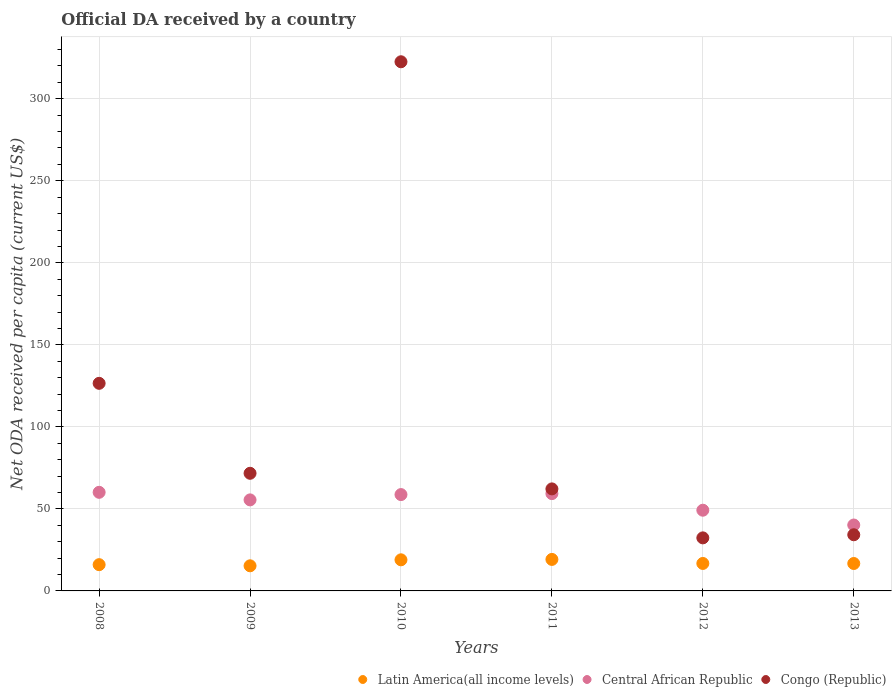How many different coloured dotlines are there?
Your answer should be compact. 3. Is the number of dotlines equal to the number of legend labels?
Your answer should be very brief. Yes. What is the ODA received in in Central African Republic in 2008?
Ensure brevity in your answer.  60.11. Across all years, what is the maximum ODA received in in Central African Republic?
Give a very brief answer. 60.11. Across all years, what is the minimum ODA received in in Congo (Republic)?
Offer a very short reply. 32.34. In which year was the ODA received in in Congo (Republic) maximum?
Provide a succinct answer. 2010. In which year was the ODA received in in Latin America(all income levels) minimum?
Provide a short and direct response. 2009. What is the total ODA received in in Congo (Republic) in the graph?
Make the answer very short. 649.54. What is the difference between the ODA received in in Latin America(all income levels) in 2010 and that in 2013?
Make the answer very short. 2.24. What is the difference between the ODA received in in Central African Republic in 2011 and the ODA received in in Congo (Republic) in 2009?
Your answer should be compact. -12.39. What is the average ODA received in in Central African Republic per year?
Ensure brevity in your answer.  53.83. In the year 2010, what is the difference between the ODA received in in Latin America(all income levels) and ODA received in in Central African Republic?
Ensure brevity in your answer.  -39.76. What is the ratio of the ODA received in in Congo (Republic) in 2008 to that in 2010?
Your response must be concise. 0.39. What is the difference between the highest and the second highest ODA received in in Central African Republic?
Ensure brevity in your answer.  0.79. What is the difference between the highest and the lowest ODA received in in Congo (Republic)?
Provide a succinct answer. 290.21. In how many years, is the ODA received in in Congo (Republic) greater than the average ODA received in in Congo (Republic) taken over all years?
Provide a succinct answer. 2. Is it the case that in every year, the sum of the ODA received in in Latin America(all income levels) and ODA received in in Central African Republic  is greater than the ODA received in in Congo (Republic)?
Make the answer very short. No. Does the ODA received in in Latin America(all income levels) monotonically increase over the years?
Your answer should be compact. No. How many years are there in the graph?
Your response must be concise. 6. What is the difference between two consecutive major ticks on the Y-axis?
Your answer should be compact. 50. Does the graph contain any zero values?
Your answer should be compact. No. Where does the legend appear in the graph?
Your response must be concise. Bottom right. How are the legend labels stacked?
Your answer should be compact. Horizontal. What is the title of the graph?
Provide a succinct answer. Official DA received by a country. What is the label or title of the Y-axis?
Your answer should be compact. Net ODA received per capita (current US$). What is the Net ODA received per capita (current US$) of Latin America(all income levels) in 2008?
Offer a terse response. 16. What is the Net ODA received per capita (current US$) in Central African Republic in 2008?
Provide a short and direct response. 60.11. What is the Net ODA received per capita (current US$) of Congo (Republic) in 2008?
Provide a succinct answer. 126.54. What is the Net ODA received per capita (current US$) of Latin America(all income levels) in 2009?
Keep it short and to the point. 15.31. What is the Net ODA received per capita (current US$) of Central African Republic in 2009?
Your response must be concise. 55.49. What is the Net ODA received per capita (current US$) in Congo (Republic) in 2009?
Keep it short and to the point. 71.7. What is the Net ODA received per capita (current US$) in Latin America(all income levels) in 2010?
Provide a short and direct response. 18.96. What is the Net ODA received per capita (current US$) of Central African Republic in 2010?
Provide a short and direct response. 58.72. What is the Net ODA received per capita (current US$) of Congo (Republic) in 2010?
Keep it short and to the point. 322.55. What is the Net ODA received per capita (current US$) in Latin America(all income levels) in 2011?
Offer a terse response. 19.2. What is the Net ODA received per capita (current US$) in Central African Republic in 2011?
Give a very brief answer. 59.32. What is the Net ODA received per capita (current US$) in Congo (Republic) in 2011?
Your answer should be compact. 62.19. What is the Net ODA received per capita (current US$) in Latin America(all income levels) in 2012?
Make the answer very short. 16.74. What is the Net ODA received per capita (current US$) of Central African Republic in 2012?
Offer a terse response. 49.19. What is the Net ODA received per capita (current US$) of Congo (Republic) in 2012?
Ensure brevity in your answer.  32.34. What is the Net ODA received per capita (current US$) in Latin America(all income levels) in 2013?
Give a very brief answer. 16.72. What is the Net ODA received per capita (current US$) in Central African Republic in 2013?
Keep it short and to the point. 40.17. What is the Net ODA received per capita (current US$) in Congo (Republic) in 2013?
Offer a terse response. 34.23. Across all years, what is the maximum Net ODA received per capita (current US$) in Latin America(all income levels)?
Provide a short and direct response. 19.2. Across all years, what is the maximum Net ODA received per capita (current US$) of Central African Republic?
Ensure brevity in your answer.  60.11. Across all years, what is the maximum Net ODA received per capita (current US$) of Congo (Republic)?
Your response must be concise. 322.55. Across all years, what is the minimum Net ODA received per capita (current US$) of Latin America(all income levels)?
Your answer should be very brief. 15.31. Across all years, what is the minimum Net ODA received per capita (current US$) in Central African Republic?
Provide a short and direct response. 40.17. Across all years, what is the minimum Net ODA received per capita (current US$) in Congo (Republic)?
Provide a succinct answer. 32.34. What is the total Net ODA received per capita (current US$) in Latin America(all income levels) in the graph?
Your answer should be compact. 102.93. What is the total Net ODA received per capita (current US$) in Central African Republic in the graph?
Ensure brevity in your answer.  323. What is the total Net ODA received per capita (current US$) of Congo (Republic) in the graph?
Provide a short and direct response. 649.54. What is the difference between the Net ODA received per capita (current US$) of Latin America(all income levels) in 2008 and that in 2009?
Ensure brevity in your answer.  0.7. What is the difference between the Net ODA received per capita (current US$) in Central African Republic in 2008 and that in 2009?
Your answer should be very brief. 4.61. What is the difference between the Net ODA received per capita (current US$) in Congo (Republic) in 2008 and that in 2009?
Give a very brief answer. 54.84. What is the difference between the Net ODA received per capita (current US$) of Latin America(all income levels) in 2008 and that in 2010?
Give a very brief answer. -2.95. What is the difference between the Net ODA received per capita (current US$) in Central African Republic in 2008 and that in 2010?
Offer a terse response. 1.39. What is the difference between the Net ODA received per capita (current US$) in Congo (Republic) in 2008 and that in 2010?
Give a very brief answer. -196.01. What is the difference between the Net ODA received per capita (current US$) of Latin America(all income levels) in 2008 and that in 2011?
Ensure brevity in your answer.  -3.2. What is the difference between the Net ODA received per capita (current US$) of Central African Republic in 2008 and that in 2011?
Offer a terse response. 0.79. What is the difference between the Net ODA received per capita (current US$) of Congo (Republic) in 2008 and that in 2011?
Your answer should be compact. 64.35. What is the difference between the Net ODA received per capita (current US$) of Latin America(all income levels) in 2008 and that in 2012?
Provide a short and direct response. -0.74. What is the difference between the Net ODA received per capita (current US$) of Central African Republic in 2008 and that in 2012?
Your answer should be compact. 10.91. What is the difference between the Net ODA received per capita (current US$) of Congo (Republic) in 2008 and that in 2012?
Your answer should be compact. 94.2. What is the difference between the Net ODA received per capita (current US$) of Latin America(all income levels) in 2008 and that in 2013?
Provide a short and direct response. -0.71. What is the difference between the Net ODA received per capita (current US$) of Central African Republic in 2008 and that in 2013?
Offer a terse response. 19.93. What is the difference between the Net ODA received per capita (current US$) of Congo (Republic) in 2008 and that in 2013?
Provide a succinct answer. 92.31. What is the difference between the Net ODA received per capita (current US$) of Latin America(all income levels) in 2009 and that in 2010?
Your response must be concise. -3.65. What is the difference between the Net ODA received per capita (current US$) in Central African Republic in 2009 and that in 2010?
Provide a short and direct response. -3.23. What is the difference between the Net ODA received per capita (current US$) in Congo (Republic) in 2009 and that in 2010?
Your answer should be very brief. -250.84. What is the difference between the Net ODA received per capita (current US$) in Latin America(all income levels) in 2009 and that in 2011?
Provide a succinct answer. -3.89. What is the difference between the Net ODA received per capita (current US$) in Central African Republic in 2009 and that in 2011?
Your answer should be compact. -3.82. What is the difference between the Net ODA received per capita (current US$) in Congo (Republic) in 2009 and that in 2011?
Provide a succinct answer. 9.51. What is the difference between the Net ODA received per capita (current US$) of Latin America(all income levels) in 2009 and that in 2012?
Your response must be concise. -1.43. What is the difference between the Net ODA received per capita (current US$) of Central African Republic in 2009 and that in 2012?
Provide a short and direct response. 6.3. What is the difference between the Net ODA received per capita (current US$) in Congo (Republic) in 2009 and that in 2012?
Offer a very short reply. 39.37. What is the difference between the Net ODA received per capita (current US$) in Latin America(all income levels) in 2009 and that in 2013?
Keep it short and to the point. -1.41. What is the difference between the Net ODA received per capita (current US$) of Central African Republic in 2009 and that in 2013?
Give a very brief answer. 15.32. What is the difference between the Net ODA received per capita (current US$) in Congo (Republic) in 2009 and that in 2013?
Offer a terse response. 37.47. What is the difference between the Net ODA received per capita (current US$) of Latin America(all income levels) in 2010 and that in 2011?
Your answer should be compact. -0.24. What is the difference between the Net ODA received per capita (current US$) in Central African Republic in 2010 and that in 2011?
Your answer should be compact. -0.6. What is the difference between the Net ODA received per capita (current US$) of Congo (Republic) in 2010 and that in 2011?
Your response must be concise. 260.36. What is the difference between the Net ODA received per capita (current US$) of Latin America(all income levels) in 2010 and that in 2012?
Your answer should be compact. 2.21. What is the difference between the Net ODA received per capita (current US$) in Central African Republic in 2010 and that in 2012?
Make the answer very short. 9.53. What is the difference between the Net ODA received per capita (current US$) in Congo (Republic) in 2010 and that in 2012?
Your answer should be compact. 290.21. What is the difference between the Net ODA received per capita (current US$) in Latin America(all income levels) in 2010 and that in 2013?
Your answer should be compact. 2.24. What is the difference between the Net ODA received per capita (current US$) of Central African Republic in 2010 and that in 2013?
Offer a very short reply. 18.55. What is the difference between the Net ODA received per capita (current US$) in Congo (Republic) in 2010 and that in 2013?
Give a very brief answer. 288.32. What is the difference between the Net ODA received per capita (current US$) in Latin America(all income levels) in 2011 and that in 2012?
Offer a very short reply. 2.46. What is the difference between the Net ODA received per capita (current US$) in Central African Republic in 2011 and that in 2012?
Keep it short and to the point. 10.12. What is the difference between the Net ODA received per capita (current US$) of Congo (Republic) in 2011 and that in 2012?
Make the answer very short. 29.85. What is the difference between the Net ODA received per capita (current US$) of Latin America(all income levels) in 2011 and that in 2013?
Offer a terse response. 2.49. What is the difference between the Net ODA received per capita (current US$) of Central African Republic in 2011 and that in 2013?
Make the answer very short. 19.14. What is the difference between the Net ODA received per capita (current US$) of Congo (Republic) in 2011 and that in 2013?
Offer a very short reply. 27.96. What is the difference between the Net ODA received per capita (current US$) of Latin America(all income levels) in 2012 and that in 2013?
Your response must be concise. 0.03. What is the difference between the Net ODA received per capita (current US$) of Central African Republic in 2012 and that in 2013?
Give a very brief answer. 9.02. What is the difference between the Net ODA received per capita (current US$) of Congo (Republic) in 2012 and that in 2013?
Your answer should be compact. -1.89. What is the difference between the Net ODA received per capita (current US$) of Latin America(all income levels) in 2008 and the Net ODA received per capita (current US$) of Central African Republic in 2009?
Ensure brevity in your answer.  -39.49. What is the difference between the Net ODA received per capita (current US$) in Latin America(all income levels) in 2008 and the Net ODA received per capita (current US$) in Congo (Republic) in 2009?
Your response must be concise. -55.7. What is the difference between the Net ODA received per capita (current US$) in Central African Republic in 2008 and the Net ODA received per capita (current US$) in Congo (Republic) in 2009?
Make the answer very short. -11.6. What is the difference between the Net ODA received per capita (current US$) of Latin America(all income levels) in 2008 and the Net ODA received per capita (current US$) of Central African Republic in 2010?
Provide a succinct answer. -42.72. What is the difference between the Net ODA received per capita (current US$) of Latin America(all income levels) in 2008 and the Net ODA received per capita (current US$) of Congo (Republic) in 2010?
Your answer should be very brief. -306.54. What is the difference between the Net ODA received per capita (current US$) of Central African Republic in 2008 and the Net ODA received per capita (current US$) of Congo (Republic) in 2010?
Provide a short and direct response. -262.44. What is the difference between the Net ODA received per capita (current US$) in Latin America(all income levels) in 2008 and the Net ODA received per capita (current US$) in Central African Republic in 2011?
Ensure brevity in your answer.  -43.31. What is the difference between the Net ODA received per capita (current US$) in Latin America(all income levels) in 2008 and the Net ODA received per capita (current US$) in Congo (Republic) in 2011?
Your response must be concise. -46.18. What is the difference between the Net ODA received per capita (current US$) of Central African Republic in 2008 and the Net ODA received per capita (current US$) of Congo (Republic) in 2011?
Give a very brief answer. -2.08. What is the difference between the Net ODA received per capita (current US$) of Latin America(all income levels) in 2008 and the Net ODA received per capita (current US$) of Central African Republic in 2012?
Offer a terse response. -33.19. What is the difference between the Net ODA received per capita (current US$) of Latin America(all income levels) in 2008 and the Net ODA received per capita (current US$) of Congo (Republic) in 2012?
Your answer should be compact. -16.33. What is the difference between the Net ODA received per capita (current US$) of Central African Republic in 2008 and the Net ODA received per capita (current US$) of Congo (Republic) in 2012?
Your answer should be compact. 27.77. What is the difference between the Net ODA received per capita (current US$) in Latin America(all income levels) in 2008 and the Net ODA received per capita (current US$) in Central African Republic in 2013?
Offer a terse response. -24.17. What is the difference between the Net ODA received per capita (current US$) of Latin America(all income levels) in 2008 and the Net ODA received per capita (current US$) of Congo (Republic) in 2013?
Give a very brief answer. -18.23. What is the difference between the Net ODA received per capita (current US$) in Central African Republic in 2008 and the Net ODA received per capita (current US$) in Congo (Republic) in 2013?
Provide a succinct answer. 25.88. What is the difference between the Net ODA received per capita (current US$) in Latin America(all income levels) in 2009 and the Net ODA received per capita (current US$) in Central African Republic in 2010?
Your response must be concise. -43.41. What is the difference between the Net ODA received per capita (current US$) in Latin America(all income levels) in 2009 and the Net ODA received per capita (current US$) in Congo (Republic) in 2010?
Provide a succinct answer. -307.24. What is the difference between the Net ODA received per capita (current US$) of Central African Republic in 2009 and the Net ODA received per capita (current US$) of Congo (Republic) in 2010?
Offer a terse response. -267.05. What is the difference between the Net ODA received per capita (current US$) of Latin America(all income levels) in 2009 and the Net ODA received per capita (current US$) of Central African Republic in 2011?
Your answer should be compact. -44.01. What is the difference between the Net ODA received per capita (current US$) in Latin America(all income levels) in 2009 and the Net ODA received per capita (current US$) in Congo (Republic) in 2011?
Keep it short and to the point. -46.88. What is the difference between the Net ODA received per capita (current US$) of Central African Republic in 2009 and the Net ODA received per capita (current US$) of Congo (Republic) in 2011?
Ensure brevity in your answer.  -6.7. What is the difference between the Net ODA received per capita (current US$) in Latin America(all income levels) in 2009 and the Net ODA received per capita (current US$) in Central African Republic in 2012?
Offer a very short reply. -33.88. What is the difference between the Net ODA received per capita (current US$) in Latin America(all income levels) in 2009 and the Net ODA received per capita (current US$) in Congo (Republic) in 2012?
Your answer should be compact. -17.03. What is the difference between the Net ODA received per capita (current US$) in Central African Republic in 2009 and the Net ODA received per capita (current US$) in Congo (Republic) in 2012?
Provide a succinct answer. 23.16. What is the difference between the Net ODA received per capita (current US$) in Latin America(all income levels) in 2009 and the Net ODA received per capita (current US$) in Central African Republic in 2013?
Ensure brevity in your answer.  -24.87. What is the difference between the Net ODA received per capita (current US$) of Latin America(all income levels) in 2009 and the Net ODA received per capita (current US$) of Congo (Republic) in 2013?
Give a very brief answer. -18.92. What is the difference between the Net ODA received per capita (current US$) in Central African Republic in 2009 and the Net ODA received per capita (current US$) in Congo (Republic) in 2013?
Offer a very short reply. 21.26. What is the difference between the Net ODA received per capita (current US$) of Latin America(all income levels) in 2010 and the Net ODA received per capita (current US$) of Central African Republic in 2011?
Make the answer very short. -40.36. What is the difference between the Net ODA received per capita (current US$) in Latin America(all income levels) in 2010 and the Net ODA received per capita (current US$) in Congo (Republic) in 2011?
Provide a succinct answer. -43.23. What is the difference between the Net ODA received per capita (current US$) in Central African Republic in 2010 and the Net ODA received per capita (current US$) in Congo (Republic) in 2011?
Your answer should be compact. -3.47. What is the difference between the Net ODA received per capita (current US$) in Latin America(all income levels) in 2010 and the Net ODA received per capita (current US$) in Central African Republic in 2012?
Your response must be concise. -30.24. What is the difference between the Net ODA received per capita (current US$) in Latin America(all income levels) in 2010 and the Net ODA received per capita (current US$) in Congo (Republic) in 2012?
Your answer should be compact. -13.38. What is the difference between the Net ODA received per capita (current US$) of Central African Republic in 2010 and the Net ODA received per capita (current US$) of Congo (Republic) in 2012?
Give a very brief answer. 26.38. What is the difference between the Net ODA received per capita (current US$) of Latin America(all income levels) in 2010 and the Net ODA received per capita (current US$) of Central African Republic in 2013?
Provide a short and direct response. -21.22. What is the difference between the Net ODA received per capita (current US$) of Latin America(all income levels) in 2010 and the Net ODA received per capita (current US$) of Congo (Republic) in 2013?
Keep it short and to the point. -15.27. What is the difference between the Net ODA received per capita (current US$) in Central African Republic in 2010 and the Net ODA received per capita (current US$) in Congo (Republic) in 2013?
Provide a succinct answer. 24.49. What is the difference between the Net ODA received per capita (current US$) of Latin America(all income levels) in 2011 and the Net ODA received per capita (current US$) of Central African Republic in 2012?
Offer a very short reply. -29.99. What is the difference between the Net ODA received per capita (current US$) in Latin America(all income levels) in 2011 and the Net ODA received per capita (current US$) in Congo (Republic) in 2012?
Ensure brevity in your answer.  -13.13. What is the difference between the Net ODA received per capita (current US$) in Central African Republic in 2011 and the Net ODA received per capita (current US$) in Congo (Republic) in 2012?
Keep it short and to the point. 26.98. What is the difference between the Net ODA received per capita (current US$) of Latin America(all income levels) in 2011 and the Net ODA received per capita (current US$) of Central African Republic in 2013?
Make the answer very short. -20.97. What is the difference between the Net ODA received per capita (current US$) in Latin America(all income levels) in 2011 and the Net ODA received per capita (current US$) in Congo (Republic) in 2013?
Keep it short and to the point. -15.03. What is the difference between the Net ODA received per capita (current US$) in Central African Republic in 2011 and the Net ODA received per capita (current US$) in Congo (Republic) in 2013?
Give a very brief answer. 25.09. What is the difference between the Net ODA received per capita (current US$) in Latin America(all income levels) in 2012 and the Net ODA received per capita (current US$) in Central African Republic in 2013?
Your answer should be compact. -23.43. What is the difference between the Net ODA received per capita (current US$) in Latin America(all income levels) in 2012 and the Net ODA received per capita (current US$) in Congo (Republic) in 2013?
Offer a very short reply. -17.49. What is the difference between the Net ODA received per capita (current US$) in Central African Republic in 2012 and the Net ODA received per capita (current US$) in Congo (Republic) in 2013?
Provide a short and direct response. 14.96. What is the average Net ODA received per capita (current US$) in Latin America(all income levels) per year?
Your answer should be very brief. 17.16. What is the average Net ODA received per capita (current US$) of Central African Republic per year?
Provide a succinct answer. 53.83. What is the average Net ODA received per capita (current US$) in Congo (Republic) per year?
Your response must be concise. 108.26. In the year 2008, what is the difference between the Net ODA received per capita (current US$) of Latin America(all income levels) and Net ODA received per capita (current US$) of Central African Republic?
Make the answer very short. -44.1. In the year 2008, what is the difference between the Net ODA received per capita (current US$) of Latin America(all income levels) and Net ODA received per capita (current US$) of Congo (Republic)?
Provide a short and direct response. -110.54. In the year 2008, what is the difference between the Net ODA received per capita (current US$) of Central African Republic and Net ODA received per capita (current US$) of Congo (Republic)?
Provide a short and direct response. -66.43. In the year 2009, what is the difference between the Net ODA received per capita (current US$) in Latin America(all income levels) and Net ODA received per capita (current US$) in Central African Republic?
Your response must be concise. -40.18. In the year 2009, what is the difference between the Net ODA received per capita (current US$) in Latin America(all income levels) and Net ODA received per capita (current US$) in Congo (Republic)?
Make the answer very short. -56.39. In the year 2009, what is the difference between the Net ODA received per capita (current US$) in Central African Republic and Net ODA received per capita (current US$) in Congo (Republic)?
Your answer should be compact. -16.21. In the year 2010, what is the difference between the Net ODA received per capita (current US$) of Latin America(all income levels) and Net ODA received per capita (current US$) of Central African Republic?
Your answer should be very brief. -39.76. In the year 2010, what is the difference between the Net ODA received per capita (current US$) of Latin America(all income levels) and Net ODA received per capita (current US$) of Congo (Republic)?
Provide a succinct answer. -303.59. In the year 2010, what is the difference between the Net ODA received per capita (current US$) of Central African Republic and Net ODA received per capita (current US$) of Congo (Republic)?
Keep it short and to the point. -263.83. In the year 2011, what is the difference between the Net ODA received per capita (current US$) of Latin America(all income levels) and Net ODA received per capita (current US$) of Central African Republic?
Your response must be concise. -40.12. In the year 2011, what is the difference between the Net ODA received per capita (current US$) of Latin America(all income levels) and Net ODA received per capita (current US$) of Congo (Republic)?
Keep it short and to the point. -42.99. In the year 2011, what is the difference between the Net ODA received per capita (current US$) in Central African Republic and Net ODA received per capita (current US$) in Congo (Republic)?
Offer a very short reply. -2.87. In the year 2012, what is the difference between the Net ODA received per capita (current US$) in Latin America(all income levels) and Net ODA received per capita (current US$) in Central African Republic?
Your response must be concise. -32.45. In the year 2012, what is the difference between the Net ODA received per capita (current US$) in Latin America(all income levels) and Net ODA received per capita (current US$) in Congo (Republic)?
Keep it short and to the point. -15.59. In the year 2012, what is the difference between the Net ODA received per capita (current US$) of Central African Republic and Net ODA received per capita (current US$) of Congo (Republic)?
Provide a short and direct response. 16.86. In the year 2013, what is the difference between the Net ODA received per capita (current US$) in Latin America(all income levels) and Net ODA received per capita (current US$) in Central African Republic?
Ensure brevity in your answer.  -23.46. In the year 2013, what is the difference between the Net ODA received per capita (current US$) of Latin America(all income levels) and Net ODA received per capita (current US$) of Congo (Republic)?
Your response must be concise. -17.51. In the year 2013, what is the difference between the Net ODA received per capita (current US$) of Central African Republic and Net ODA received per capita (current US$) of Congo (Republic)?
Provide a short and direct response. 5.94. What is the ratio of the Net ODA received per capita (current US$) of Latin America(all income levels) in 2008 to that in 2009?
Give a very brief answer. 1.05. What is the ratio of the Net ODA received per capita (current US$) in Central African Republic in 2008 to that in 2009?
Make the answer very short. 1.08. What is the ratio of the Net ODA received per capita (current US$) in Congo (Republic) in 2008 to that in 2009?
Offer a terse response. 1.76. What is the ratio of the Net ODA received per capita (current US$) of Latin America(all income levels) in 2008 to that in 2010?
Your answer should be compact. 0.84. What is the ratio of the Net ODA received per capita (current US$) in Central African Republic in 2008 to that in 2010?
Your answer should be compact. 1.02. What is the ratio of the Net ODA received per capita (current US$) in Congo (Republic) in 2008 to that in 2010?
Make the answer very short. 0.39. What is the ratio of the Net ODA received per capita (current US$) in Latin America(all income levels) in 2008 to that in 2011?
Keep it short and to the point. 0.83. What is the ratio of the Net ODA received per capita (current US$) of Central African Republic in 2008 to that in 2011?
Your answer should be compact. 1.01. What is the ratio of the Net ODA received per capita (current US$) of Congo (Republic) in 2008 to that in 2011?
Your answer should be compact. 2.03. What is the ratio of the Net ODA received per capita (current US$) of Latin America(all income levels) in 2008 to that in 2012?
Keep it short and to the point. 0.96. What is the ratio of the Net ODA received per capita (current US$) of Central African Republic in 2008 to that in 2012?
Your response must be concise. 1.22. What is the ratio of the Net ODA received per capita (current US$) of Congo (Republic) in 2008 to that in 2012?
Your response must be concise. 3.91. What is the ratio of the Net ODA received per capita (current US$) of Latin America(all income levels) in 2008 to that in 2013?
Your answer should be compact. 0.96. What is the ratio of the Net ODA received per capita (current US$) of Central African Republic in 2008 to that in 2013?
Make the answer very short. 1.5. What is the ratio of the Net ODA received per capita (current US$) of Congo (Republic) in 2008 to that in 2013?
Provide a succinct answer. 3.7. What is the ratio of the Net ODA received per capita (current US$) in Latin America(all income levels) in 2009 to that in 2010?
Your response must be concise. 0.81. What is the ratio of the Net ODA received per capita (current US$) in Central African Republic in 2009 to that in 2010?
Ensure brevity in your answer.  0.94. What is the ratio of the Net ODA received per capita (current US$) of Congo (Republic) in 2009 to that in 2010?
Your answer should be compact. 0.22. What is the ratio of the Net ODA received per capita (current US$) in Latin America(all income levels) in 2009 to that in 2011?
Your answer should be very brief. 0.8. What is the ratio of the Net ODA received per capita (current US$) of Central African Republic in 2009 to that in 2011?
Offer a terse response. 0.94. What is the ratio of the Net ODA received per capita (current US$) of Congo (Republic) in 2009 to that in 2011?
Your response must be concise. 1.15. What is the ratio of the Net ODA received per capita (current US$) of Latin America(all income levels) in 2009 to that in 2012?
Give a very brief answer. 0.91. What is the ratio of the Net ODA received per capita (current US$) in Central African Republic in 2009 to that in 2012?
Ensure brevity in your answer.  1.13. What is the ratio of the Net ODA received per capita (current US$) of Congo (Republic) in 2009 to that in 2012?
Keep it short and to the point. 2.22. What is the ratio of the Net ODA received per capita (current US$) in Latin America(all income levels) in 2009 to that in 2013?
Your answer should be very brief. 0.92. What is the ratio of the Net ODA received per capita (current US$) in Central African Republic in 2009 to that in 2013?
Your response must be concise. 1.38. What is the ratio of the Net ODA received per capita (current US$) in Congo (Republic) in 2009 to that in 2013?
Provide a short and direct response. 2.09. What is the ratio of the Net ODA received per capita (current US$) of Latin America(all income levels) in 2010 to that in 2011?
Provide a short and direct response. 0.99. What is the ratio of the Net ODA received per capita (current US$) of Congo (Republic) in 2010 to that in 2011?
Keep it short and to the point. 5.19. What is the ratio of the Net ODA received per capita (current US$) in Latin America(all income levels) in 2010 to that in 2012?
Offer a very short reply. 1.13. What is the ratio of the Net ODA received per capita (current US$) of Central African Republic in 2010 to that in 2012?
Your answer should be very brief. 1.19. What is the ratio of the Net ODA received per capita (current US$) in Congo (Republic) in 2010 to that in 2012?
Your answer should be very brief. 9.97. What is the ratio of the Net ODA received per capita (current US$) of Latin America(all income levels) in 2010 to that in 2013?
Your answer should be very brief. 1.13. What is the ratio of the Net ODA received per capita (current US$) in Central African Republic in 2010 to that in 2013?
Provide a short and direct response. 1.46. What is the ratio of the Net ODA received per capita (current US$) in Congo (Republic) in 2010 to that in 2013?
Give a very brief answer. 9.42. What is the ratio of the Net ODA received per capita (current US$) in Latin America(all income levels) in 2011 to that in 2012?
Your response must be concise. 1.15. What is the ratio of the Net ODA received per capita (current US$) of Central African Republic in 2011 to that in 2012?
Make the answer very short. 1.21. What is the ratio of the Net ODA received per capita (current US$) of Congo (Republic) in 2011 to that in 2012?
Make the answer very short. 1.92. What is the ratio of the Net ODA received per capita (current US$) of Latin America(all income levels) in 2011 to that in 2013?
Your answer should be compact. 1.15. What is the ratio of the Net ODA received per capita (current US$) in Central African Republic in 2011 to that in 2013?
Give a very brief answer. 1.48. What is the ratio of the Net ODA received per capita (current US$) of Congo (Republic) in 2011 to that in 2013?
Keep it short and to the point. 1.82. What is the ratio of the Net ODA received per capita (current US$) in Latin America(all income levels) in 2012 to that in 2013?
Keep it short and to the point. 1. What is the ratio of the Net ODA received per capita (current US$) of Central African Republic in 2012 to that in 2013?
Your response must be concise. 1.22. What is the ratio of the Net ODA received per capita (current US$) of Congo (Republic) in 2012 to that in 2013?
Make the answer very short. 0.94. What is the difference between the highest and the second highest Net ODA received per capita (current US$) in Latin America(all income levels)?
Ensure brevity in your answer.  0.24. What is the difference between the highest and the second highest Net ODA received per capita (current US$) of Central African Republic?
Ensure brevity in your answer.  0.79. What is the difference between the highest and the second highest Net ODA received per capita (current US$) of Congo (Republic)?
Offer a very short reply. 196.01. What is the difference between the highest and the lowest Net ODA received per capita (current US$) in Latin America(all income levels)?
Provide a short and direct response. 3.89. What is the difference between the highest and the lowest Net ODA received per capita (current US$) of Central African Republic?
Give a very brief answer. 19.93. What is the difference between the highest and the lowest Net ODA received per capita (current US$) of Congo (Republic)?
Make the answer very short. 290.21. 